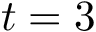<formula> <loc_0><loc_0><loc_500><loc_500>t = 3</formula> 